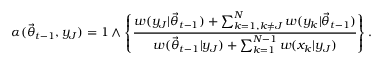Convert formula to latex. <formula><loc_0><loc_0><loc_500><loc_500>\alpha ( { \vec { \theta } } _ { t - 1 } , y _ { J } ) = 1 \wedge \left \{ \frac { w ( y _ { J } | { \vec { \theta } } _ { t - 1 } ) + \sum _ { k = 1 , k \neq J } ^ { N } w ( y _ { k } | { \vec { \theta } } _ { t - 1 } ) } { w ( { \vec { \theta } } _ { t - 1 } | y _ { J } ) + \sum _ { k = 1 } ^ { N - 1 } w ( x _ { k } | y _ { J } ) } \right \} .</formula> 